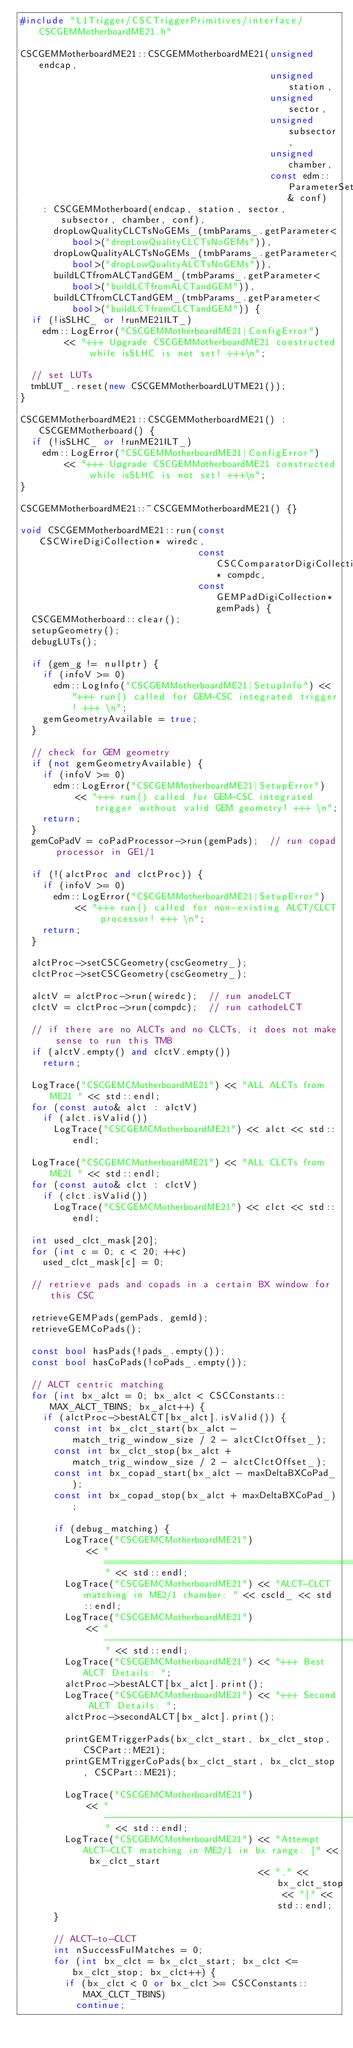Convert code to text. <code><loc_0><loc_0><loc_500><loc_500><_C++_>#include "L1Trigger/CSCTriggerPrimitives/interface/CSCGEMMotherboardME21.h"

CSCGEMMotherboardME21::CSCGEMMotherboardME21(unsigned endcap,
                                             unsigned station,
                                             unsigned sector,
                                             unsigned subsector,
                                             unsigned chamber,
                                             const edm::ParameterSet& conf)
    : CSCGEMMotherboard(endcap, station, sector, subsector, chamber, conf),
      dropLowQualityCLCTsNoGEMs_(tmbParams_.getParameter<bool>("dropLowQualityCLCTsNoGEMs")),
      dropLowQualityALCTsNoGEMs_(tmbParams_.getParameter<bool>("dropLowQualityALCTsNoGEMs")),
      buildLCTfromALCTandGEM_(tmbParams_.getParameter<bool>("buildLCTfromALCTandGEM")),
      buildLCTfromCLCTandGEM_(tmbParams_.getParameter<bool>("buildLCTfromCLCTandGEM")) {
  if (!isSLHC_ or !runME21ILT_)
    edm::LogError("CSCGEMMotherboardME21|ConfigError")
        << "+++ Upgrade CSCGEMMotherboardME21 constructed while isSLHC is not set! +++\n";

  // set LUTs
  tmbLUT_.reset(new CSCGEMMotherboardLUTME21());
}

CSCGEMMotherboardME21::CSCGEMMotherboardME21() : CSCGEMMotherboard() {
  if (!isSLHC_ or !runME21ILT_)
    edm::LogError("CSCGEMMotherboardME21|ConfigError")
        << "+++ Upgrade CSCGEMMotherboardME21 constructed while isSLHC is not set! +++\n";
}

CSCGEMMotherboardME21::~CSCGEMMotherboardME21() {}

void CSCGEMMotherboardME21::run(const CSCWireDigiCollection* wiredc,
                                const CSCComparatorDigiCollection* compdc,
                                const GEMPadDigiCollection* gemPads) {
  CSCGEMMotherboard::clear();
  setupGeometry();
  debugLUTs();

  if (gem_g != nullptr) {
    if (infoV >= 0)
      edm::LogInfo("CSCGEMMotherboardME21|SetupInfo") << "+++ run() called for GEM-CSC integrated trigger! +++ \n";
    gemGeometryAvailable = true;
  }

  // check for GEM geometry
  if (not gemGeometryAvailable) {
    if (infoV >= 0)
      edm::LogError("CSCGEMMotherboardME21|SetupError")
          << "+++ run() called for GEM-CSC integrated trigger without valid GEM geometry! +++ \n";
    return;
  }
  gemCoPadV = coPadProcessor->run(gemPads);  // run copad processor in GE1/1

  if (!(alctProc and clctProc)) {
    if (infoV >= 0)
      edm::LogError("CSCGEMMotherboardME21|SetupError")
          << "+++ run() called for non-existing ALCT/CLCT processor! +++ \n";
    return;
  }

  alctProc->setCSCGeometry(cscGeometry_);
  clctProc->setCSCGeometry(cscGeometry_);

  alctV = alctProc->run(wiredc);  // run anodeLCT
  clctV = clctProc->run(compdc);  // run cathodeLCT

  // if there are no ALCTs and no CLCTs, it does not make sense to run this TMB
  if (alctV.empty() and clctV.empty())
    return;

  LogTrace("CSCGEMCMotherboardME21") << "ALL ALCTs from ME21 " << std::endl;
  for (const auto& alct : alctV)
    if (alct.isValid())
      LogTrace("CSCGEMCMotherboardME21") << alct << std::endl;

  LogTrace("CSCGEMCMotherboardME21") << "ALL CLCTs from ME21 " << std::endl;
  for (const auto& clct : clctV)
    if (clct.isValid())
      LogTrace("CSCGEMCMotherboardME21") << clct << std::endl;

  int used_clct_mask[20];
  for (int c = 0; c < 20; ++c)
    used_clct_mask[c] = 0;

  // retrieve pads and copads in a certain BX window for this CSC

  retrieveGEMPads(gemPads, gemId);
  retrieveGEMCoPads();

  const bool hasPads(!pads_.empty());
  const bool hasCoPads(!coPads_.empty());

  // ALCT centric matching
  for (int bx_alct = 0; bx_alct < CSCConstants::MAX_ALCT_TBINS; bx_alct++) {
    if (alctProc->bestALCT[bx_alct].isValid()) {
      const int bx_clct_start(bx_alct - match_trig_window_size / 2 - alctClctOffset_);
      const int bx_clct_stop(bx_alct + match_trig_window_size / 2 - alctClctOffset_);
      const int bx_copad_start(bx_alct - maxDeltaBXCoPad_);
      const int bx_copad_stop(bx_alct + maxDeltaBXCoPad_);

      if (debug_matching) {
        LogTrace("CSCGEMCMotherboardME21")
            << "========================================================================" << std::endl;
        LogTrace("CSCGEMCMotherboardME21") << "ALCT-CLCT matching in ME2/1 chamber: " << cscId_ << std::endl;
        LogTrace("CSCGEMCMotherboardME21")
            << "------------------------------------------------------------------------" << std::endl;
        LogTrace("CSCGEMCMotherboardME21") << "+++ Best ALCT Details: ";
        alctProc->bestALCT[bx_alct].print();
        LogTrace("CSCGEMCMotherboardME21") << "+++ Second ALCT Details: ";
        alctProc->secondALCT[bx_alct].print();

        printGEMTriggerPads(bx_clct_start, bx_clct_stop, CSCPart::ME21);
        printGEMTriggerCoPads(bx_clct_start, bx_clct_stop, CSCPart::ME21);

        LogTrace("CSCGEMCMotherboardME21")
            << "------------------------------------------------------------------------" << std::endl;
        LogTrace("CSCGEMCMotherboardME21") << "Attempt ALCT-CLCT matching in ME2/1 in bx range: [" << bx_clct_start
                                           << "," << bx_clct_stop << "]" << std::endl;
      }

      // ALCT-to-CLCT
      int nSuccessFulMatches = 0;
      for (int bx_clct = bx_clct_start; bx_clct <= bx_clct_stop; bx_clct++) {
        if (bx_clct < 0 or bx_clct >= CSCConstants::MAX_CLCT_TBINS)
          continue;</code> 